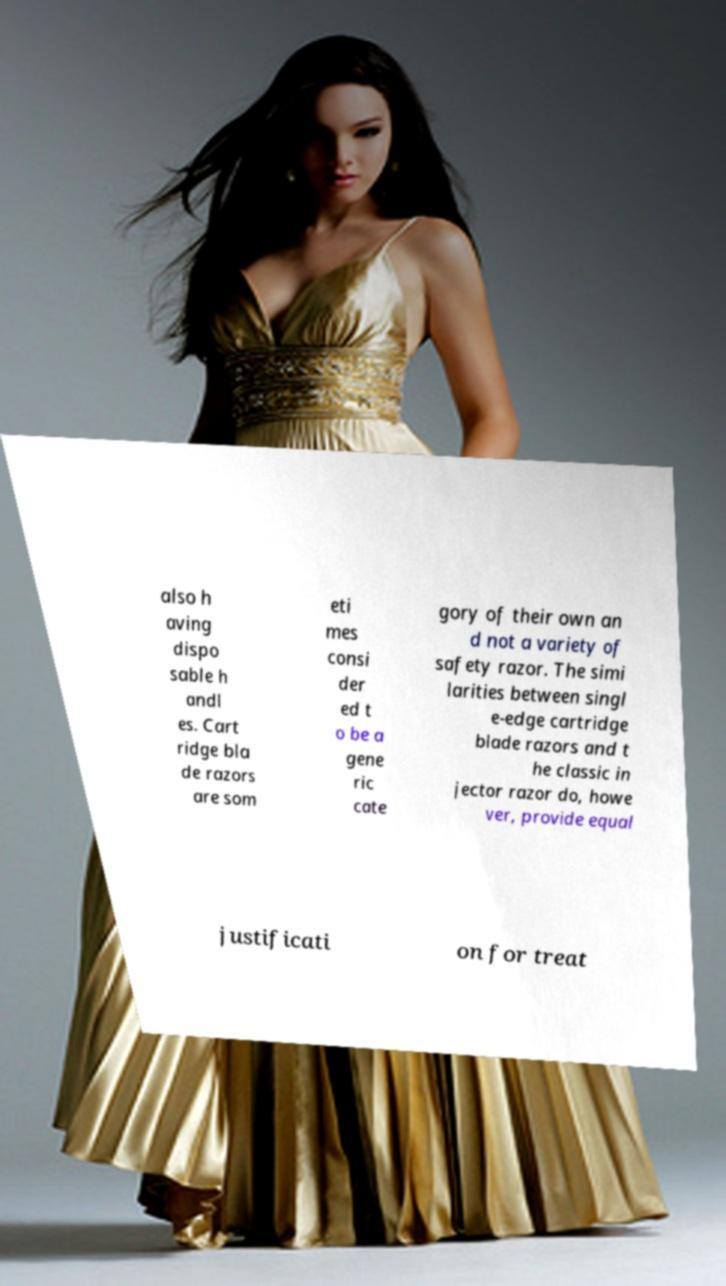Could you assist in decoding the text presented in this image and type it out clearly? also h aving dispo sable h andl es. Cart ridge bla de razors are som eti mes consi der ed t o be a gene ric cate gory of their own an d not a variety of safety razor. The simi larities between singl e-edge cartridge blade razors and t he classic in jector razor do, howe ver, provide equal justificati on for treat 